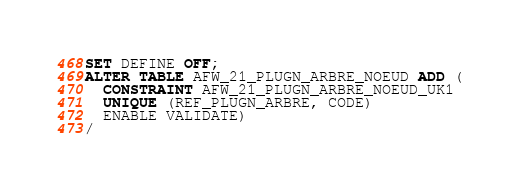Convert code to text. <code><loc_0><loc_0><loc_500><loc_500><_SQL_>SET DEFINE OFF;
ALTER TABLE AFW_21_PLUGN_ARBRE_NOEUD ADD (
  CONSTRAINT AFW_21_PLUGN_ARBRE_NOEUD_UK1
  UNIQUE (REF_PLUGN_ARBRE, CODE)
  ENABLE VALIDATE)
/
</code> 